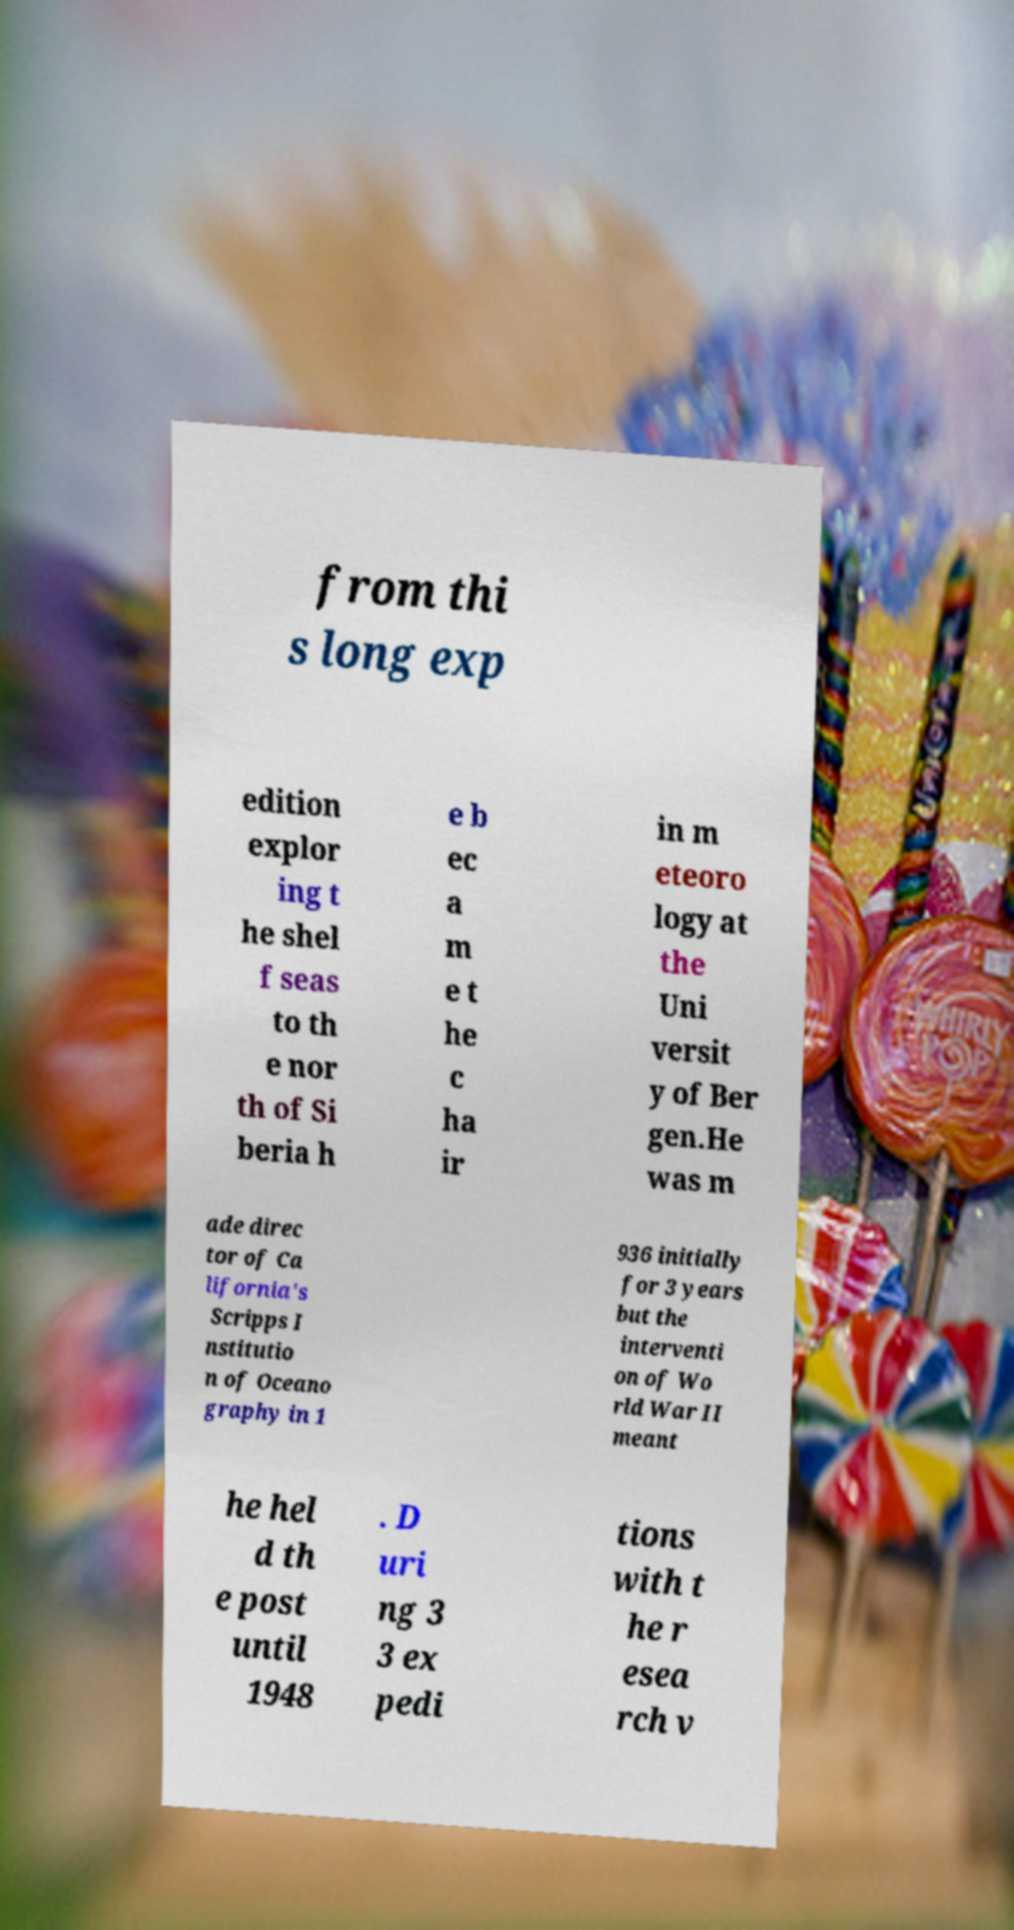Can you accurately transcribe the text from the provided image for me? from thi s long exp edition explor ing t he shel f seas to th e nor th of Si beria h e b ec a m e t he c ha ir in m eteoro logy at the Uni versit y of Ber gen.He was m ade direc tor of Ca lifornia's Scripps I nstitutio n of Oceano graphy in 1 936 initially for 3 years but the interventi on of Wo rld War II meant he hel d th e post until 1948 . D uri ng 3 3 ex pedi tions with t he r esea rch v 